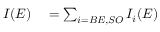<formula> <loc_0><loc_0><loc_500><loc_500>\begin{array} { r l } { I ( E ) } & = \sum _ { i = B E , S O } I _ { i } ( E ) } \end{array}</formula> 